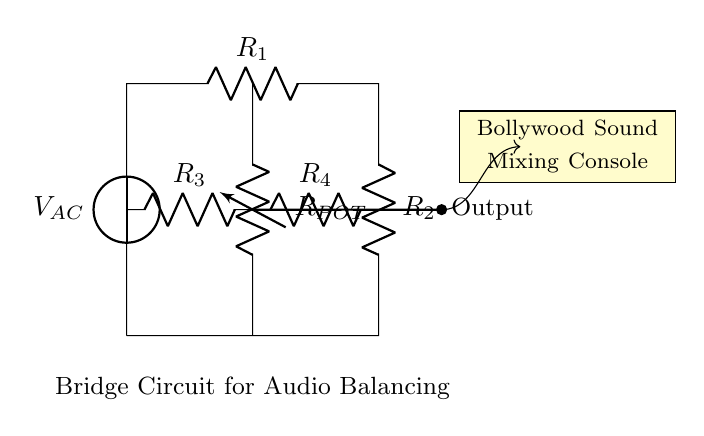What is the source voltage type in the circuit? The source voltage in the circuit is labeled as V_AC, indicating it is an alternating current voltage.
Answer: Alternating current What are the resistances in the bridge circuit? The bridge circuit consists of four resistors: R1, R2, R3, and R4, each labeled in the circuit.
Answer: R1, R2, R3, R4 How many resistors are in parallel in this circuit? In the circuit, R3 and R4 are connected in parallel in the upper part of the bridge, providing one path for the current.
Answer: Two What is the purpose of the potentiometer in the circuit? The potentiometer, labeled as R_POT, is used for adjusting resistance and balancing audio signals, allowing for fine-tuning of the output.
Answer: Audio balancing Which component serves as the output in this circuit? The output is indicated with a thick line and connected to a node, suggesting that the output voltage can be taken from this point in the circuit.
Answer: Output How can the circuit be described overall? The entire circuit serves as a bridge circuit for audio balancing, used specifically in sound mixing consoles, ensuring signals are optimized for sound production.
Answer: Audio balancing bridge 